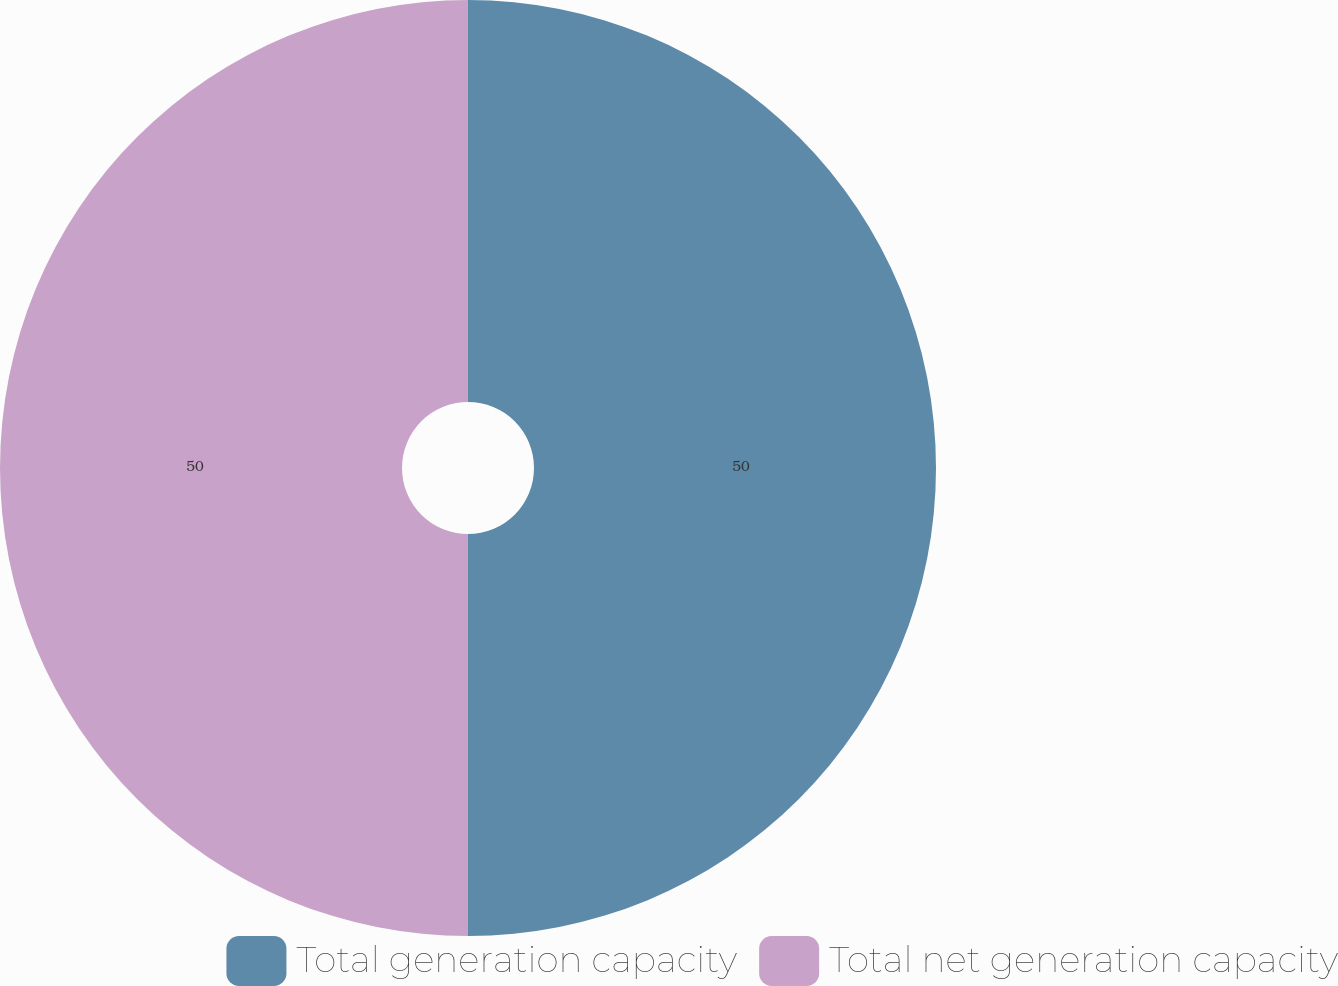Convert chart. <chart><loc_0><loc_0><loc_500><loc_500><pie_chart><fcel>Total generation capacity<fcel>Total net generation capacity<nl><fcel>50.0%<fcel>50.0%<nl></chart> 